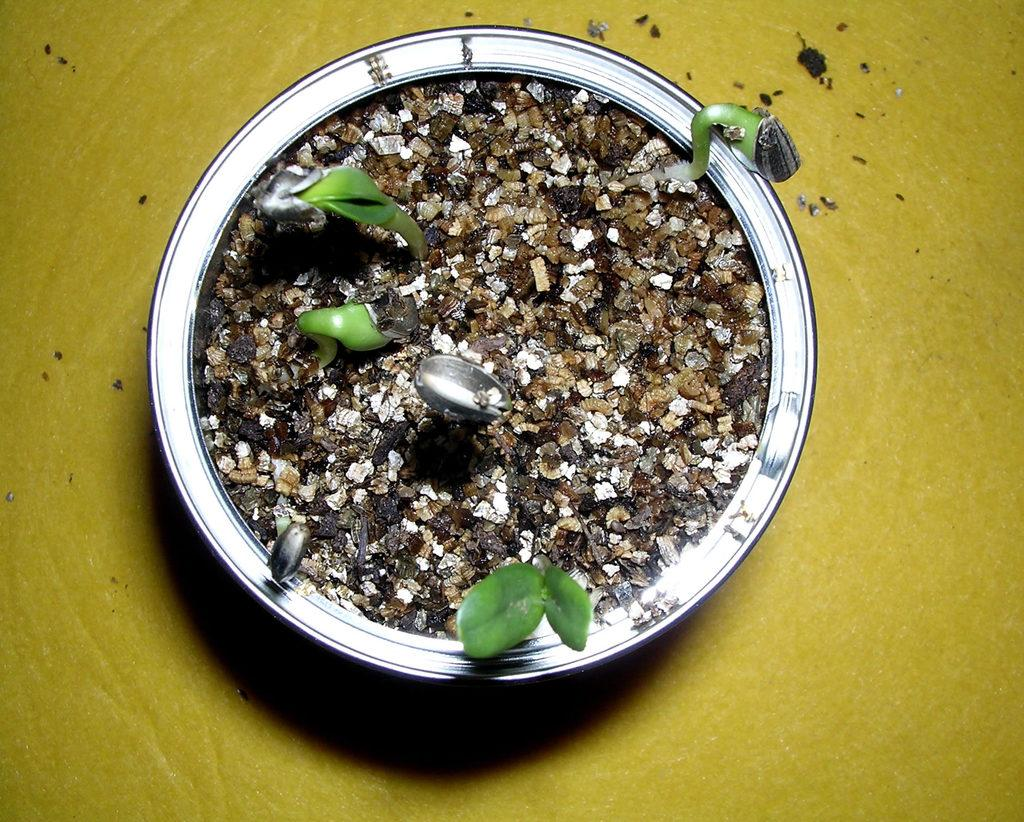What is in the pot in the image? There are plants in the pot. What color is the background at the bottom of the image? The background at the bottom of the image is yellow. How much cheese is hanging from the cobweb in the image? There is no cheese or cobweb present in the image. 